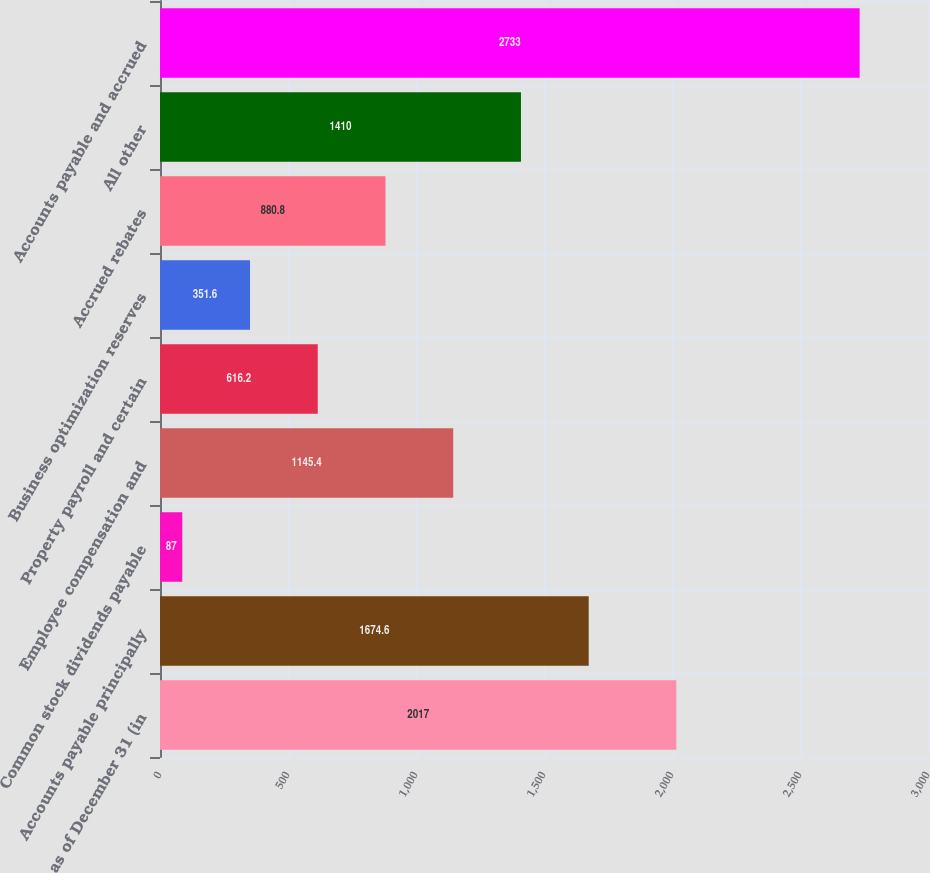<chart> <loc_0><loc_0><loc_500><loc_500><bar_chart><fcel>as of December 31 (in<fcel>Accounts payable principally<fcel>Common stock dividends payable<fcel>Employee compensation and<fcel>Property payroll and certain<fcel>Business optimization reserves<fcel>Accrued rebates<fcel>All other<fcel>Accounts payable and accrued<nl><fcel>2017<fcel>1674.6<fcel>87<fcel>1145.4<fcel>616.2<fcel>351.6<fcel>880.8<fcel>1410<fcel>2733<nl></chart> 